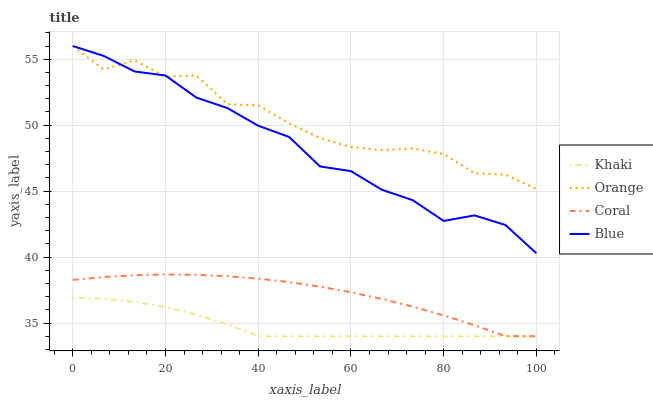Does Blue have the minimum area under the curve?
Answer yes or no. No. Does Blue have the maximum area under the curve?
Answer yes or no. No. Is Blue the smoothest?
Answer yes or no. No. Is Blue the roughest?
Answer yes or no. No. Does Blue have the lowest value?
Answer yes or no. No. Does Coral have the highest value?
Answer yes or no. No. Is Khaki less than Orange?
Answer yes or no. Yes. Is Blue greater than Khaki?
Answer yes or no. Yes. Does Khaki intersect Orange?
Answer yes or no. No. 